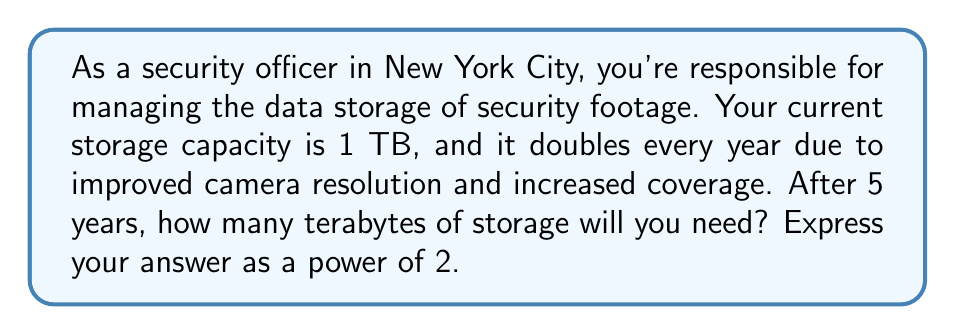Show me your answer to this math problem. Let's approach this step-by-step:

1) We start with 1 TB of storage, which can be written as $2^0$ TB.

2) Each year, the storage doubles. This means we multiply by 2 each year:
   - After 1 year: $1 \cdot 2 = 2^1$ TB
   - After 2 years: $2 \cdot 2 = 2^2$ TB
   - After 3 years: $4 \cdot 2 = 2^3$ TB
   - And so on...

3) We can see a pattern forming. After n years, the storage will be $2^n$ TB.

4) In this case, we're asked about the storage after 5 years.

5) Therefore, the storage after 5 years will be $2^5$ TB.

6) We can calculate this:

   $$2^5 = 2 \cdot 2 \cdot 2 \cdot 2 \cdot 2 = 32$$

Thus, after 5 years, you will need 32 TB of storage.
Answer: $2^5$ TB 